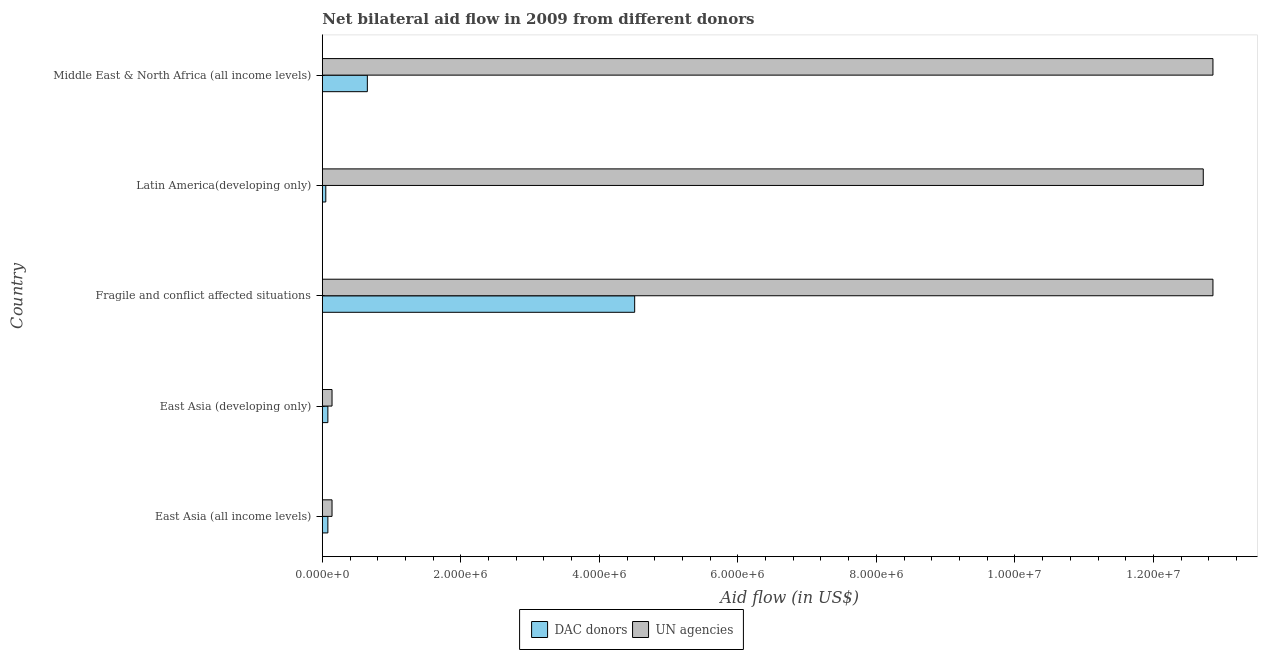How many different coloured bars are there?
Offer a terse response. 2. What is the label of the 5th group of bars from the top?
Give a very brief answer. East Asia (all income levels). What is the aid flow from un agencies in East Asia (developing only)?
Your answer should be compact. 1.40e+05. Across all countries, what is the maximum aid flow from dac donors?
Make the answer very short. 4.51e+06. Across all countries, what is the minimum aid flow from un agencies?
Offer a terse response. 1.40e+05. In which country was the aid flow from dac donors maximum?
Give a very brief answer. Fragile and conflict affected situations. In which country was the aid flow from dac donors minimum?
Keep it short and to the point. Latin America(developing only). What is the total aid flow from dac donors in the graph?
Your response must be concise. 5.37e+06. What is the difference between the aid flow from un agencies in Fragile and conflict affected situations and that in Latin America(developing only)?
Your answer should be very brief. 1.40e+05. What is the difference between the aid flow from dac donors in East Asia (all income levels) and the aid flow from un agencies in Latin America(developing only)?
Offer a terse response. -1.26e+07. What is the average aid flow from dac donors per country?
Offer a terse response. 1.07e+06. What is the difference between the aid flow from un agencies and aid flow from dac donors in Latin America(developing only)?
Your answer should be very brief. 1.27e+07. In how many countries, is the aid flow from dac donors greater than 10400000 US$?
Make the answer very short. 0. What is the ratio of the aid flow from dac donors in Latin America(developing only) to that in Middle East & North Africa (all income levels)?
Ensure brevity in your answer.  0.08. Is the aid flow from dac donors in Fragile and conflict affected situations less than that in Latin America(developing only)?
Provide a short and direct response. No. Is the difference between the aid flow from dac donors in East Asia (all income levels) and Latin America(developing only) greater than the difference between the aid flow from un agencies in East Asia (all income levels) and Latin America(developing only)?
Give a very brief answer. Yes. What is the difference between the highest and the second highest aid flow from un agencies?
Provide a succinct answer. 0. What is the difference between the highest and the lowest aid flow from dac donors?
Make the answer very short. 4.46e+06. What does the 2nd bar from the top in Middle East & North Africa (all income levels) represents?
Your answer should be compact. DAC donors. What does the 1st bar from the bottom in Middle East & North Africa (all income levels) represents?
Offer a terse response. DAC donors. Are all the bars in the graph horizontal?
Offer a terse response. Yes. What is the difference between two consecutive major ticks on the X-axis?
Your answer should be compact. 2.00e+06. Are the values on the major ticks of X-axis written in scientific E-notation?
Your answer should be very brief. Yes. Does the graph contain grids?
Your response must be concise. No. Where does the legend appear in the graph?
Ensure brevity in your answer.  Bottom center. How many legend labels are there?
Provide a short and direct response. 2. What is the title of the graph?
Make the answer very short. Net bilateral aid flow in 2009 from different donors. What is the label or title of the X-axis?
Provide a short and direct response. Aid flow (in US$). What is the Aid flow (in US$) in DAC donors in East Asia (all income levels)?
Give a very brief answer. 8.00e+04. What is the Aid flow (in US$) in DAC donors in East Asia (developing only)?
Make the answer very short. 8.00e+04. What is the Aid flow (in US$) of UN agencies in East Asia (developing only)?
Keep it short and to the point. 1.40e+05. What is the Aid flow (in US$) in DAC donors in Fragile and conflict affected situations?
Make the answer very short. 4.51e+06. What is the Aid flow (in US$) in UN agencies in Fragile and conflict affected situations?
Your response must be concise. 1.29e+07. What is the Aid flow (in US$) in DAC donors in Latin America(developing only)?
Your answer should be compact. 5.00e+04. What is the Aid flow (in US$) in UN agencies in Latin America(developing only)?
Your answer should be compact. 1.27e+07. What is the Aid flow (in US$) in DAC donors in Middle East & North Africa (all income levels)?
Make the answer very short. 6.50e+05. What is the Aid flow (in US$) in UN agencies in Middle East & North Africa (all income levels)?
Your answer should be compact. 1.29e+07. Across all countries, what is the maximum Aid flow (in US$) of DAC donors?
Offer a terse response. 4.51e+06. Across all countries, what is the maximum Aid flow (in US$) in UN agencies?
Provide a short and direct response. 1.29e+07. Across all countries, what is the minimum Aid flow (in US$) of DAC donors?
Ensure brevity in your answer.  5.00e+04. What is the total Aid flow (in US$) in DAC donors in the graph?
Keep it short and to the point. 5.37e+06. What is the total Aid flow (in US$) of UN agencies in the graph?
Keep it short and to the point. 3.87e+07. What is the difference between the Aid flow (in US$) of DAC donors in East Asia (all income levels) and that in Fragile and conflict affected situations?
Give a very brief answer. -4.43e+06. What is the difference between the Aid flow (in US$) of UN agencies in East Asia (all income levels) and that in Fragile and conflict affected situations?
Provide a succinct answer. -1.27e+07. What is the difference between the Aid flow (in US$) of DAC donors in East Asia (all income levels) and that in Latin America(developing only)?
Ensure brevity in your answer.  3.00e+04. What is the difference between the Aid flow (in US$) in UN agencies in East Asia (all income levels) and that in Latin America(developing only)?
Offer a very short reply. -1.26e+07. What is the difference between the Aid flow (in US$) in DAC donors in East Asia (all income levels) and that in Middle East & North Africa (all income levels)?
Your answer should be very brief. -5.70e+05. What is the difference between the Aid flow (in US$) of UN agencies in East Asia (all income levels) and that in Middle East & North Africa (all income levels)?
Offer a terse response. -1.27e+07. What is the difference between the Aid flow (in US$) of DAC donors in East Asia (developing only) and that in Fragile and conflict affected situations?
Your answer should be very brief. -4.43e+06. What is the difference between the Aid flow (in US$) in UN agencies in East Asia (developing only) and that in Fragile and conflict affected situations?
Offer a terse response. -1.27e+07. What is the difference between the Aid flow (in US$) in DAC donors in East Asia (developing only) and that in Latin America(developing only)?
Give a very brief answer. 3.00e+04. What is the difference between the Aid flow (in US$) in UN agencies in East Asia (developing only) and that in Latin America(developing only)?
Your response must be concise. -1.26e+07. What is the difference between the Aid flow (in US$) of DAC donors in East Asia (developing only) and that in Middle East & North Africa (all income levels)?
Give a very brief answer. -5.70e+05. What is the difference between the Aid flow (in US$) in UN agencies in East Asia (developing only) and that in Middle East & North Africa (all income levels)?
Provide a short and direct response. -1.27e+07. What is the difference between the Aid flow (in US$) in DAC donors in Fragile and conflict affected situations and that in Latin America(developing only)?
Your answer should be compact. 4.46e+06. What is the difference between the Aid flow (in US$) of DAC donors in Fragile and conflict affected situations and that in Middle East & North Africa (all income levels)?
Make the answer very short. 3.86e+06. What is the difference between the Aid flow (in US$) of UN agencies in Fragile and conflict affected situations and that in Middle East & North Africa (all income levels)?
Make the answer very short. 0. What is the difference between the Aid flow (in US$) in DAC donors in Latin America(developing only) and that in Middle East & North Africa (all income levels)?
Your answer should be compact. -6.00e+05. What is the difference between the Aid flow (in US$) in UN agencies in Latin America(developing only) and that in Middle East & North Africa (all income levels)?
Offer a terse response. -1.40e+05. What is the difference between the Aid flow (in US$) in DAC donors in East Asia (all income levels) and the Aid flow (in US$) in UN agencies in Fragile and conflict affected situations?
Provide a short and direct response. -1.28e+07. What is the difference between the Aid flow (in US$) in DAC donors in East Asia (all income levels) and the Aid flow (in US$) in UN agencies in Latin America(developing only)?
Provide a succinct answer. -1.26e+07. What is the difference between the Aid flow (in US$) of DAC donors in East Asia (all income levels) and the Aid flow (in US$) of UN agencies in Middle East & North Africa (all income levels)?
Give a very brief answer. -1.28e+07. What is the difference between the Aid flow (in US$) in DAC donors in East Asia (developing only) and the Aid flow (in US$) in UN agencies in Fragile and conflict affected situations?
Make the answer very short. -1.28e+07. What is the difference between the Aid flow (in US$) in DAC donors in East Asia (developing only) and the Aid flow (in US$) in UN agencies in Latin America(developing only)?
Keep it short and to the point. -1.26e+07. What is the difference between the Aid flow (in US$) of DAC donors in East Asia (developing only) and the Aid flow (in US$) of UN agencies in Middle East & North Africa (all income levels)?
Keep it short and to the point. -1.28e+07. What is the difference between the Aid flow (in US$) in DAC donors in Fragile and conflict affected situations and the Aid flow (in US$) in UN agencies in Latin America(developing only)?
Offer a very short reply. -8.21e+06. What is the difference between the Aid flow (in US$) in DAC donors in Fragile and conflict affected situations and the Aid flow (in US$) in UN agencies in Middle East & North Africa (all income levels)?
Provide a short and direct response. -8.35e+06. What is the difference between the Aid flow (in US$) of DAC donors in Latin America(developing only) and the Aid flow (in US$) of UN agencies in Middle East & North Africa (all income levels)?
Provide a short and direct response. -1.28e+07. What is the average Aid flow (in US$) in DAC donors per country?
Your response must be concise. 1.07e+06. What is the average Aid flow (in US$) in UN agencies per country?
Offer a very short reply. 7.74e+06. What is the difference between the Aid flow (in US$) of DAC donors and Aid flow (in US$) of UN agencies in East Asia (all income levels)?
Give a very brief answer. -6.00e+04. What is the difference between the Aid flow (in US$) of DAC donors and Aid flow (in US$) of UN agencies in East Asia (developing only)?
Ensure brevity in your answer.  -6.00e+04. What is the difference between the Aid flow (in US$) in DAC donors and Aid flow (in US$) in UN agencies in Fragile and conflict affected situations?
Keep it short and to the point. -8.35e+06. What is the difference between the Aid flow (in US$) in DAC donors and Aid flow (in US$) in UN agencies in Latin America(developing only)?
Your response must be concise. -1.27e+07. What is the difference between the Aid flow (in US$) of DAC donors and Aid flow (in US$) of UN agencies in Middle East & North Africa (all income levels)?
Your answer should be very brief. -1.22e+07. What is the ratio of the Aid flow (in US$) of DAC donors in East Asia (all income levels) to that in East Asia (developing only)?
Give a very brief answer. 1. What is the ratio of the Aid flow (in US$) of UN agencies in East Asia (all income levels) to that in East Asia (developing only)?
Provide a short and direct response. 1. What is the ratio of the Aid flow (in US$) in DAC donors in East Asia (all income levels) to that in Fragile and conflict affected situations?
Provide a succinct answer. 0.02. What is the ratio of the Aid flow (in US$) in UN agencies in East Asia (all income levels) to that in Fragile and conflict affected situations?
Provide a short and direct response. 0.01. What is the ratio of the Aid flow (in US$) in UN agencies in East Asia (all income levels) to that in Latin America(developing only)?
Provide a short and direct response. 0.01. What is the ratio of the Aid flow (in US$) in DAC donors in East Asia (all income levels) to that in Middle East & North Africa (all income levels)?
Your answer should be very brief. 0.12. What is the ratio of the Aid flow (in US$) of UN agencies in East Asia (all income levels) to that in Middle East & North Africa (all income levels)?
Give a very brief answer. 0.01. What is the ratio of the Aid flow (in US$) of DAC donors in East Asia (developing only) to that in Fragile and conflict affected situations?
Provide a short and direct response. 0.02. What is the ratio of the Aid flow (in US$) of UN agencies in East Asia (developing only) to that in Fragile and conflict affected situations?
Provide a short and direct response. 0.01. What is the ratio of the Aid flow (in US$) in UN agencies in East Asia (developing only) to that in Latin America(developing only)?
Ensure brevity in your answer.  0.01. What is the ratio of the Aid flow (in US$) of DAC donors in East Asia (developing only) to that in Middle East & North Africa (all income levels)?
Provide a short and direct response. 0.12. What is the ratio of the Aid flow (in US$) in UN agencies in East Asia (developing only) to that in Middle East & North Africa (all income levels)?
Offer a terse response. 0.01. What is the ratio of the Aid flow (in US$) in DAC donors in Fragile and conflict affected situations to that in Latin America(developing only)?
Provide a short and direct response. 90.2. What is the ratio of the Aid flow (in US$) of DAC donors in Fragile and conflict affected situations to that in Middle East & North Africa (all income levels)?
Ensure brevity in your answer.  6.94. What is the ratio of the Aid flow (in US$) of DAC donors in Latin America(developing only) to that in Middle East & North Africa (all income levels)?
Keep it short and to the point. 0.08. What is the difference between the highest and the second highest Aid flow (in US$) in DAC donors?
Make the answer very short. 3.86e+06. What is the difference between the highest and the second highest Aid flow (in US$) in UN agencies?
Offer a terse response. 0. What is the difference between the highest and the lowest Aid flow (in US$) of DAC donors?
Offer a very short reply. 4.46e+06. What is the difference between the highest and the lowest Aid flow (in US$) of UN agencies?
Ensure brevity in your answer.  1.27e+07. 